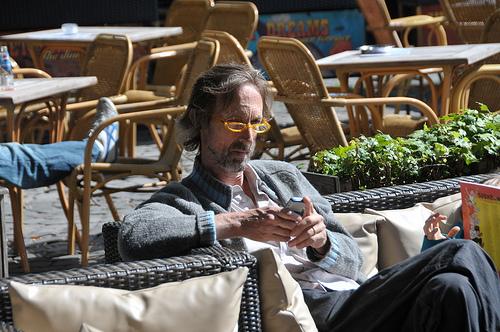What kind of pants does the person in the background have on?
Keep it brief. Jeans. Is there a slight chill in the air?
Answer briefly. Yes. What color is the man's glasses?
Quick response, please. Yellow. 